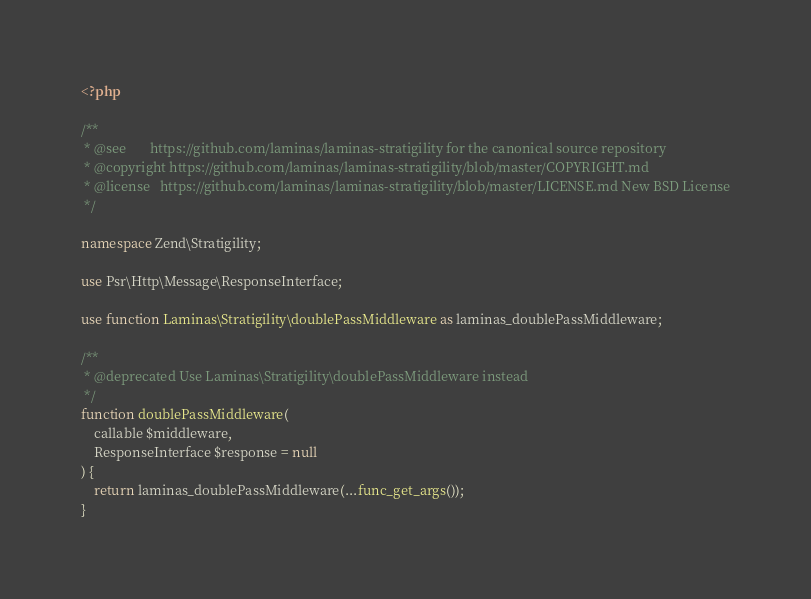<code> <loc_0><loc_0><loc_500><loc_500><_PHP_><?php

/**
 * @see       https://github.com/laminas/laminas-stratigility for the canonical source repository
 * @copyright https://github.com/laminas/laminas-stratigility/blob/master/COPYRIGHT.md
 * @license   https://github.com/laminas/laminas-stratigility/blob/master/LICENSE.md New BSD License
 */

namespace Zend\Stratigility;

use Psr\Http\Message\ResponseInterface;

use function Laminas\Stratigility\doublePassMiddleware as laminas_doublePassMiddleware;

/**
 * @deprecated Use Laminas\Stratigility\doublePassMiddleware instead
 */
function doublePassMiddleware(
    callable $middleware,
    ResponseInterface $response = null
) {
    return laminas_doublePassMiddleware(...func_get_args());
}
</code> 